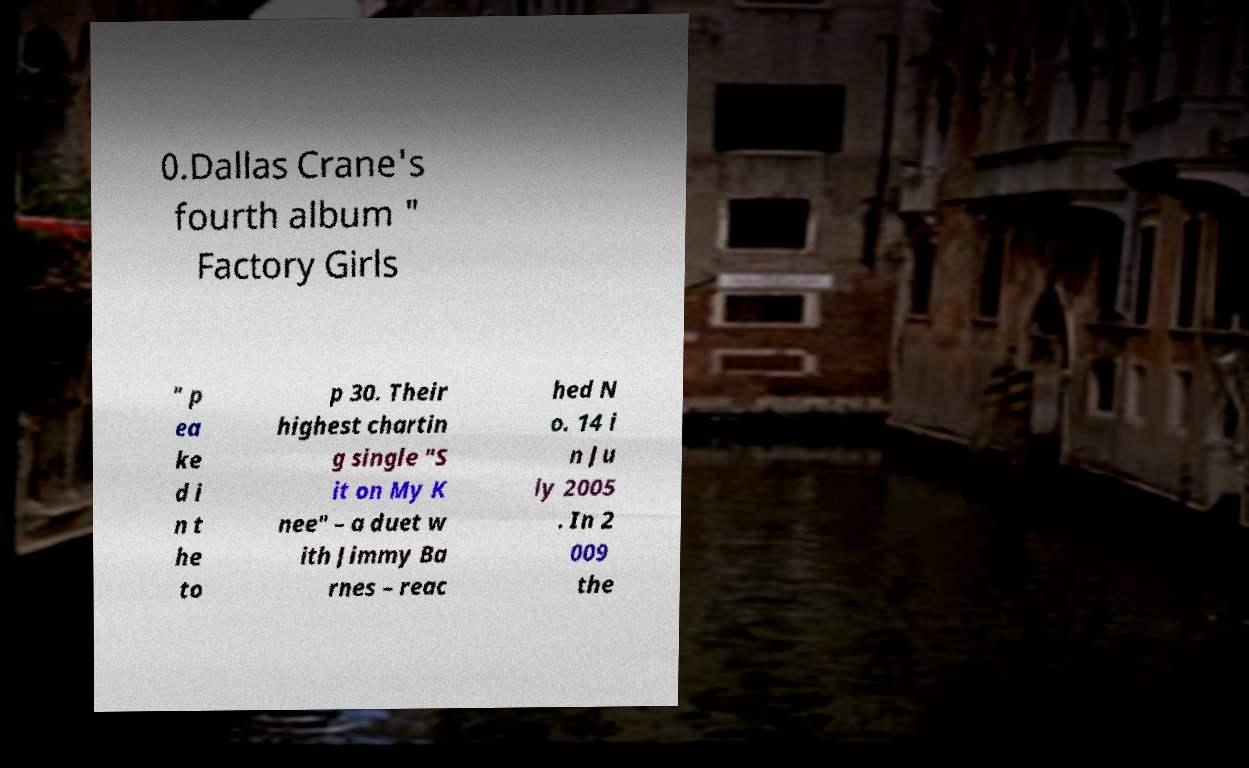Can you accurately transcribe the text from the provided image for me? 0.Dallas Crane's fourth album " Factory Girls " p ea ke d i n t he to p 30. Their highest chartin g single "S it on My K nee" – a duet w ith Jimmy Ba rnes – reac hed N o. 14 i n Ju ly 2005 . In 2 009 the 